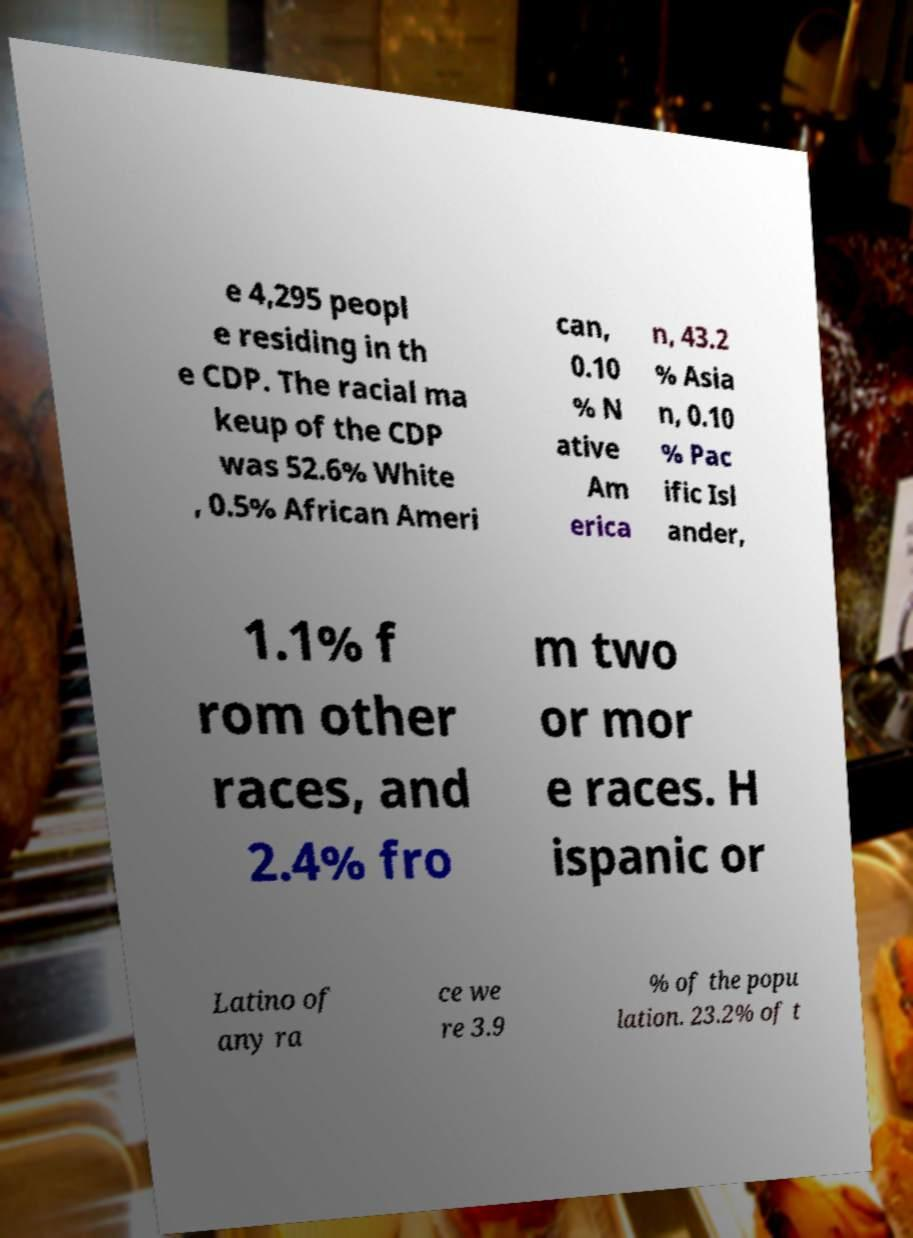Could you extract and type out the text from this image? e 4,295 peopl e residing in th e CDP. The racial ma keup of the CDP was 52.6% White , 0.5% African Ameri can, 0.10 % N ative Am erica n, 43.2 % Asia n, 0.10 % Pac ific Isl ander, 1.1% f rom other races, and 2.4% fro m two or mor e races. H ispanic or Latino of any ra ce we re 3.9 % of the popu lation. 23.2% of t 